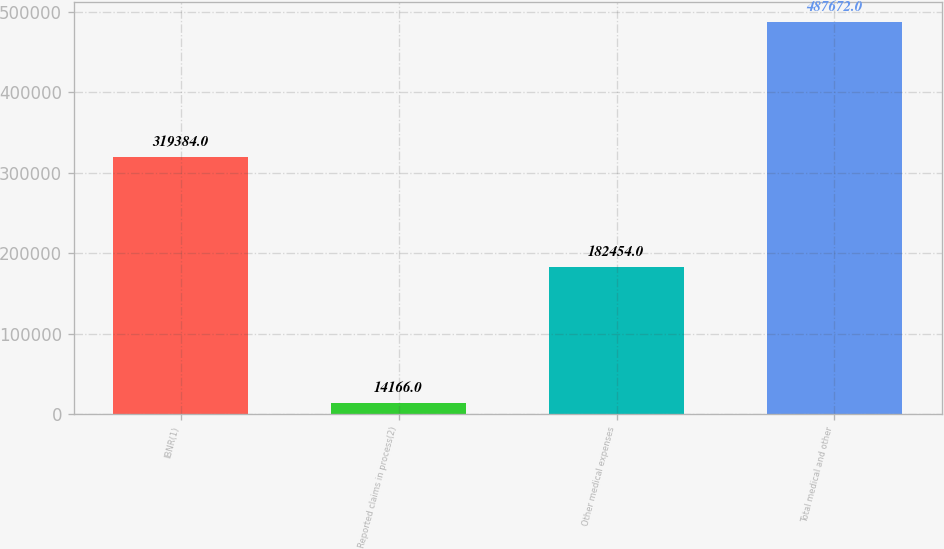Convert chart to OTSL. <chart><loc_0><loc_0><loc_500><loc_500><bar_chart><fcel>IBNR(1)<fcel>Reported claims in process(2)<fcel>Other medical expenses<fcel>Total medical and other<nl><fcel>319384<fcel>14166<fcel>182454<fcel>487672<nl></chart> 